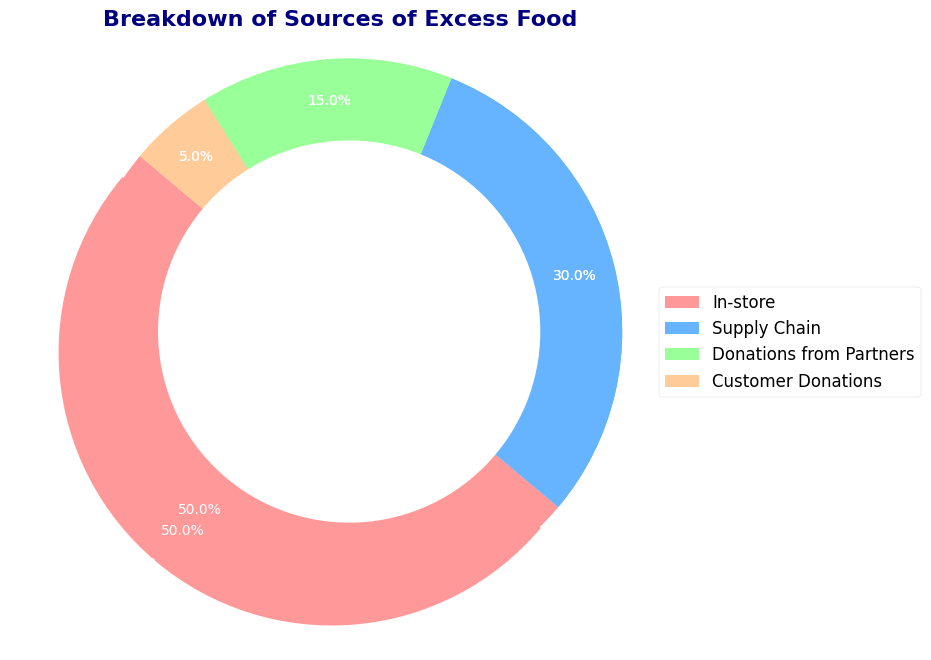What percentage of excess food comes from in-store sources? The pie chart shows that the in-store category accounts for the largest slice, highlighted by a slight explosion. The percentage inside the slice shows 50.0%.
Answer: 50.0% How does the quantity of excess food from donations from partners compare to that from customer donations? The pie chart shows that donations from partners account for 15.0%, whereas customer donations account for 5.0%. Comparing 15.0% to 5.0%, donations from partners are larger.
Answer: Donations from partners are larger Which two sources together account for more than half of the excess food? The pie chart shows that in-store sources account for 50.0% and supply chain sources account for 30.0%. Together, they add up to 80.0%, which is more than half.
Answer: In-store sources and supply chain sources How much more food is generated by the supply chain compared to customer donations? The pie chart shows 30.0% for the supply chain and 5.0% for customer donations. The difference is 30.0% - 5.0% = 25.0%.
Answer: 25.0% more What is the smallest source of excess food? The pie chart indicates that the smallest source of excess food is customer donations, represented by the smallest slice and labeled as 5.0%.
Answer: Customer donations What two sources equally divide 20.0% of excess food? The pie chart shows that donations from partners account for 15.0% and customer donations account for 5.0%. Together, they add up to 20.0%.
Answer: Donations from partners and customer donations Which color represents donations from partners, and what percentage does it occupy? The pie chart shows donations from partners in a light blue color (third-largest slice) with a label indicating it occupies 15.0%.
Answer: Light blue, 15.0% If we combine the contributions from donations from partners and customer donations, what portion of the food do they represent? The pie chart shows donations from partners as 15.0% and customer donations as 5.0%. Together, they represent 15.0% + 5.0% = 20.0%.
Answer: 20.0% How much more food does the largest source generate compared to the smallest source? The pie chart shows that in-store sources generate 50.0% and customer donations generate 5.0%. The difference is 50.0% - 5.0% = 45.0%.
Answer: 45.0% more 